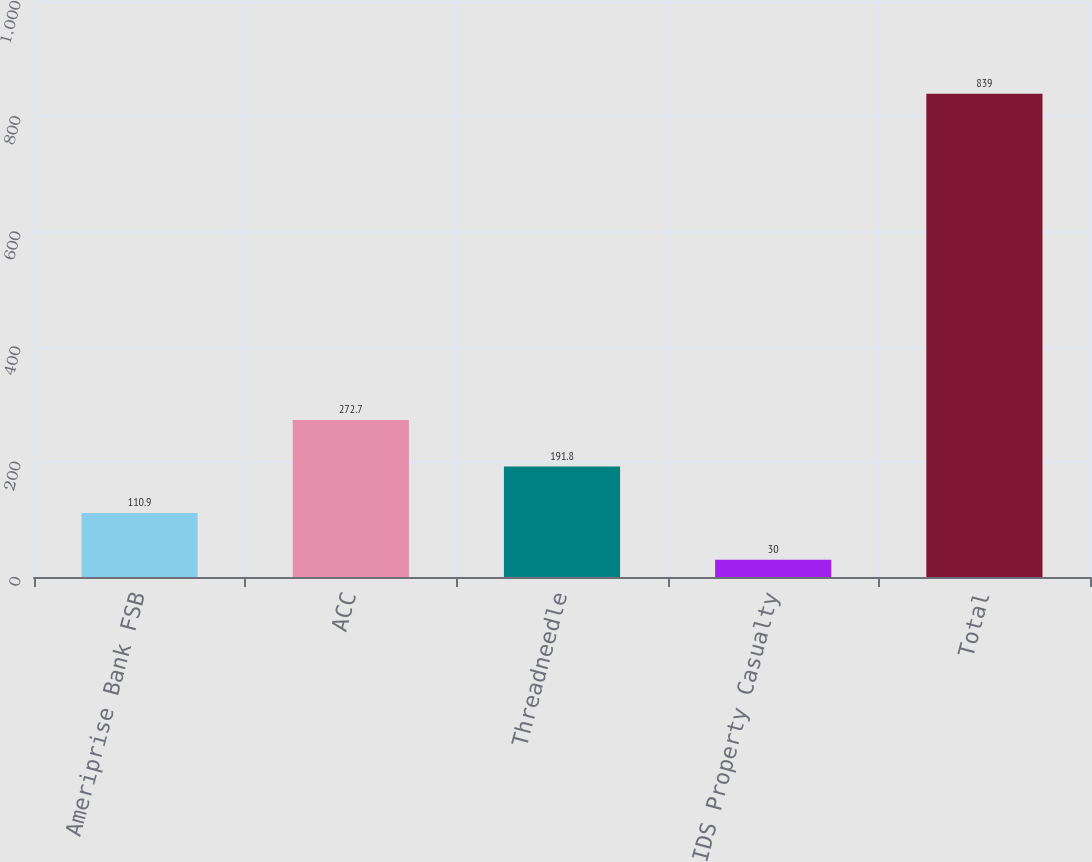Convert chart. <chart><loc_0><loc_0><loc_500><loc_500><bar_chart><fcel>Ameriprise Bank FSB<fcel>ACC<fcel>Threadneedle<fcel>IDS Property Casualty<fcel>Total<nl><fcel>110.9<fcel>272.7<fcel>191.8<fcel>30<fcel>839<nl></chart> 